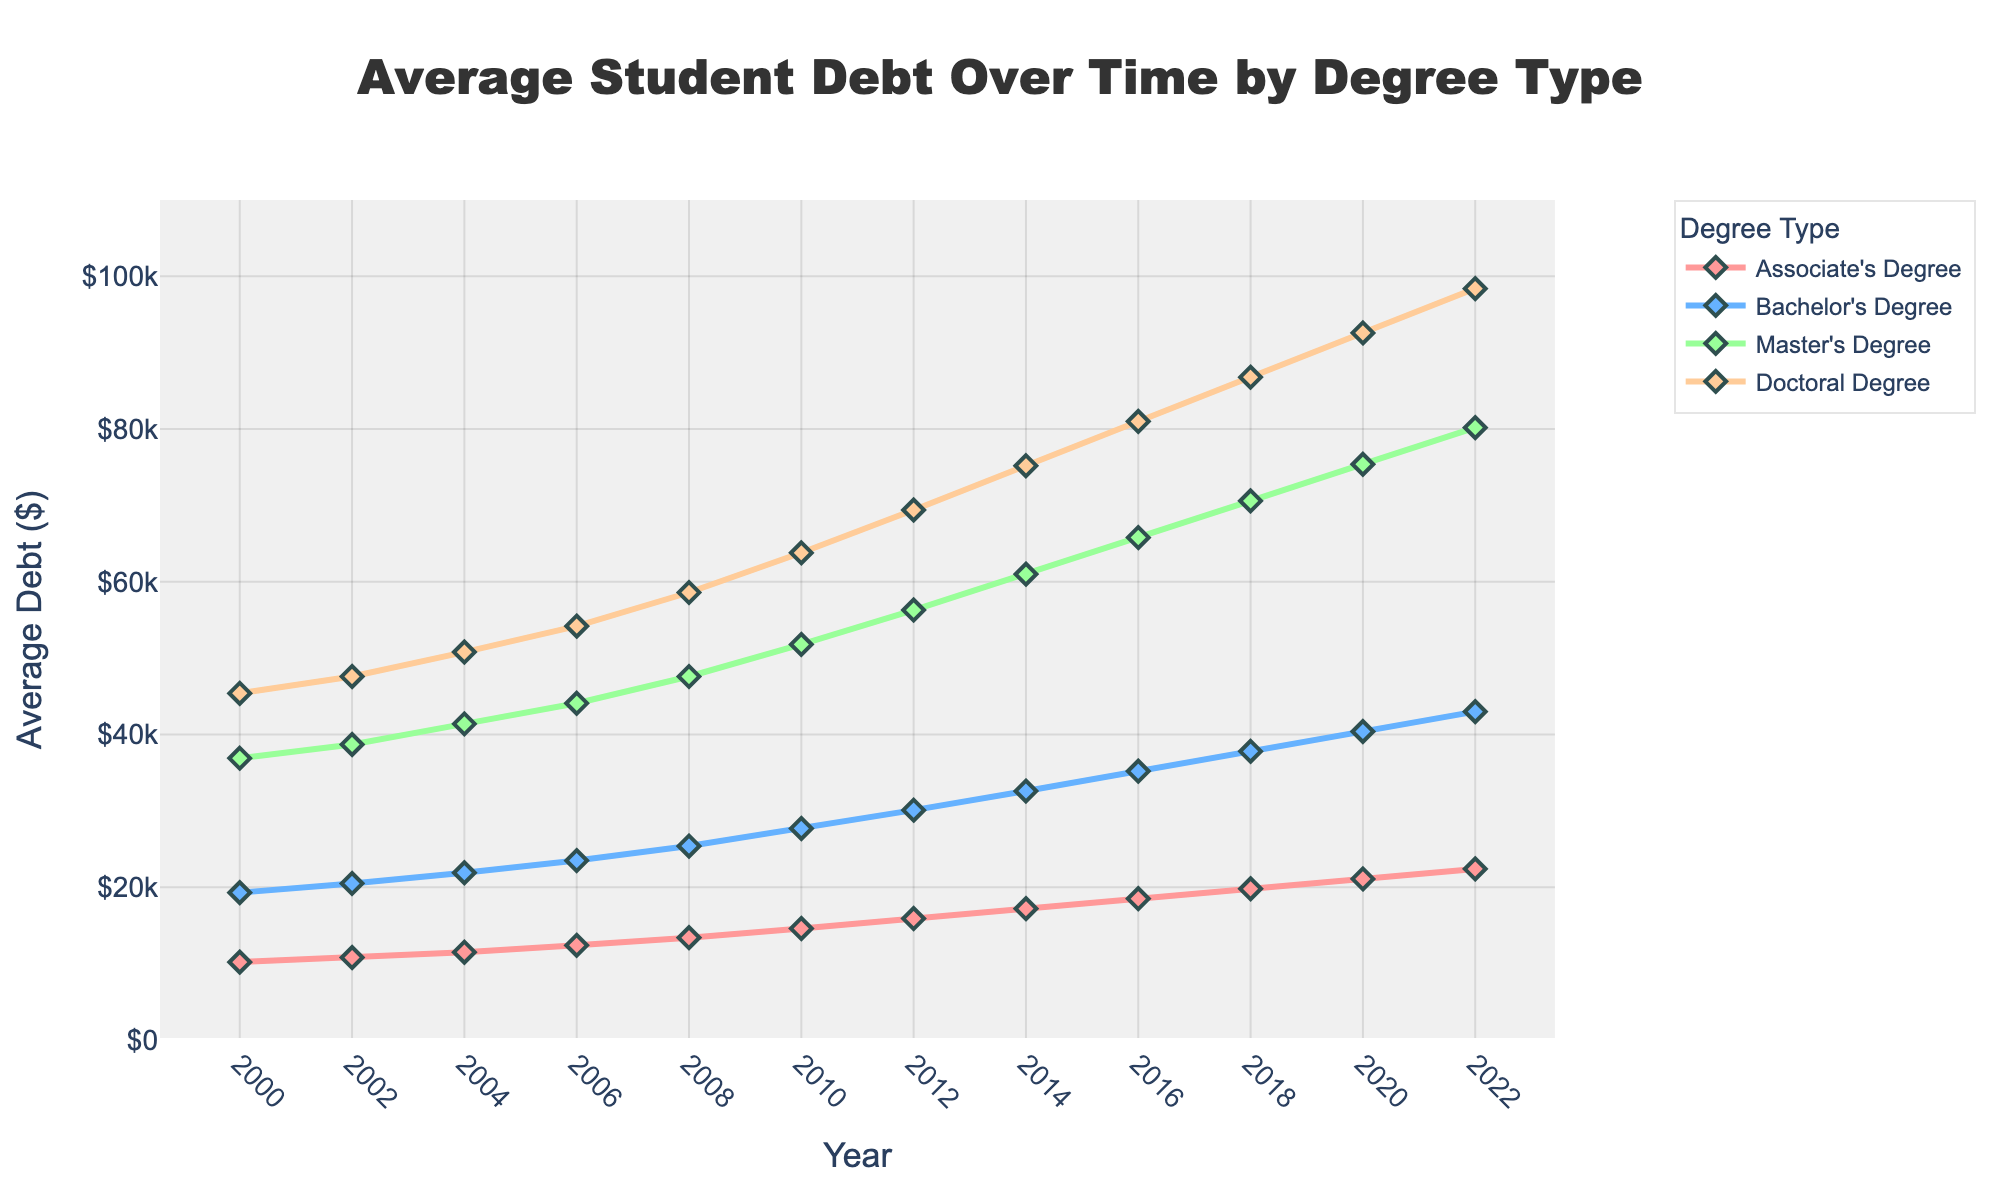What degree type has the highest average student debt in 2022? By looking at the figure and identifying the highest line at the point corresponding to the year 2022, you can see which degree type has the highest value. The Doctoral Degree line is the highest at $98,400.
Answer: Doctoral Degree What is the trend in average student debt for Bachelor's degrees between 2000 and 2022? Observing the graph, the Bachelor's Degree line shows a consistent upward trend from $19,300 in 2000 to $43,000 in 2022.
Answer: Increasing Which degree type had the smallest increase in average debt from 2000 to 2022? Calculate the increase for each degree type:  
Associate's Degree: $22,400 - $10,200 = $12,200  
Bachelor's Degree: $43,000 - $19,300 = $23,700  
Master's Degree: $80,200 - $36,900 = $43,300  
Doctoral Degree: $98,400 - $45,400 = $53,000  
The smallest increase is for Associate's Degree.
Answer: Associate's Degree How much did the average debt for Master’s degrees change from 2010 to 2020? Look at the Master's Degree line at 2010 and 2020. The average debt changes from $51,800 in 2010 to $75,400 in 2020. The difference is $75,400 - $51,800 = $23,600.
Answer: $23,600 Which degree type experienced the most consistent growth in average debt over the years? By visually examining the slopes of each line, the Associate’s Degree line appears to have a steady, consistent growth compared to the others.
Answer: Associate's Degree In 2018, what is the difference in average debt between Bachelor’s Degrees and Master’s Degrees? From the figure, in 2018, the average debt for Bachelor’s Degrees is $37,800 and for Master’s Degrees is $70,600. The difference is $70,600 - $37,800 = $32,800.
Answer: $32,800 What color represents the Doctoral Degree in the figure? By referring to the color legend in the figure, the Doctoral Degree line is marked with the color orange.
Answer: Orange In which year did the average debt for Bachelor's Degrees exceed $30,000? Checking the graph, the Bachelor's Degree line crosses the $30,000 mark in 2012.
Answer: 2012 Between which years did Master's Degrees see the sharpest increase in average debt? By observing the steepness of the Master's Degree line, the sharpest increase is from 2010 to 2012, where the line rises significantly.
Answer: 2010 to 2012 What is the average increase in debt per year for Associate’s Degrees from 2000 to 2022? Calculate the annual increase using the initial and final values: ($22,400 - $10,200) / (2022 - 2000) = $12,200 / 22 = approximately $554.55 per year.
Answer: $554.55 per year 